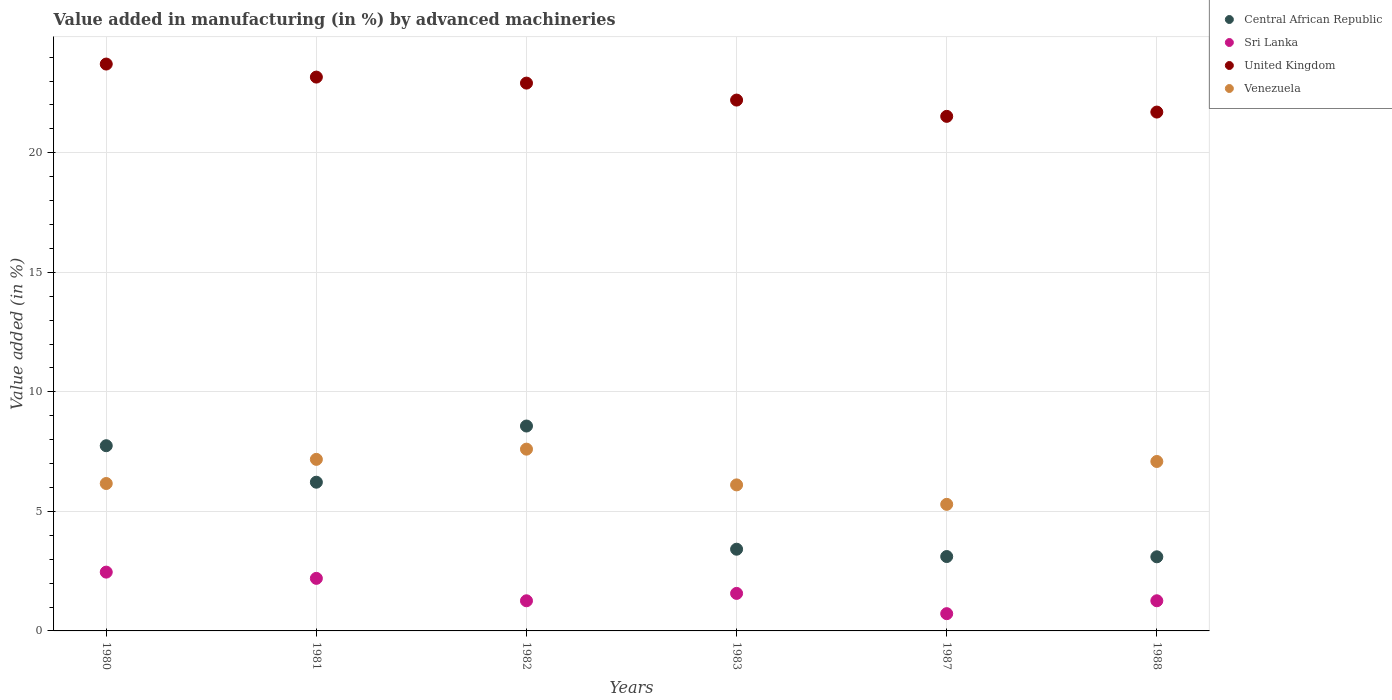How many different coloured dotlines are there?
Give a very brief answer. 4. Is the number of dotlines equal to the number of legend labels?
Your answer should be very brief. Yes. What is the percentage of value added in manufacturing by advanced machineries in Venezuela in 1983?
Your answer should be compact. 6.11. Across all years, what is the maximum percentage of value added in manufacturing by advanced machineries in Central African Republic?
Offer a very short reply. 8.57. Across all years, what is the minimum percentage of value added in manufacturing by advanced machineries in Venezuela?
Give a very brief answer. 5.29. In which year was the percentage of value added in manufacturing by advanced machineries in Central African Republic maximum?
Your response must be concise. 1982. In which year was the percentage of value added in manufacturing by advanced machineries in Central African Republic minimum?
Ensure brevity in your answer.  1988. What is the total percentage of value added in manufacturing by advanced machineries in Sri Lanka in the graph?
Ensure brevity in your answer.  9.47. What is the difference between the percentage of value added in manufacturing by advanced machineries in United Kingdom in 1980 and that in 1987?
Ensure brevity in your answer.  2.19. What is the difference between the percentage of value added in manufacturing by advanced machineries in Sri Lanka in 1981 and the percentage of value added in manufacturing by advanced machineries in Central African Republic in 1982?
Your answer should be compact. -6.37. What is the average percentage of value added in manufacturing by advanced machineries in Sri Lanka per year?
Provide a succinct answer. 1.58. In the year 1981, what is the difference between the percentage of value added in manufacturing by advanced machineries in Central African Republic and percentage of value added in manufacturing by advanced machineries in United Kingdom?
Provide a short and direct response. -16.95. In how many years, is the percentage of value added in manufacturing by advanced machineries in United Kingdom greater than 21 %?
Provide a succinct answer. 6. What is the ratio of the percentage of value added in manufacturing by advanced machineries in Sri Lanka in 1980 to that in 1983?
Your answer should be compact. 1.57. Is the difference between the percentage of value added in manufacturing by advanced machineries in Central African Republic in 1983 and 1988 greater than the difference between the percentage of value added in manufacturing by advanced machineries in United Kingdom in 1983 and 1988?
Your response must be concise. No. What is the difference between the highest and the second highest percentage of value added in manufacturing by advanced machineries in Sri Lanka?
Ensure brevity in your answer.  0.26. What is the difference between the highest and the lowest percentage of value added in manufacturing by advanced machineries in Central African Republic?
Your response must be concise. 5.47. Is the sum of the percentage of value added in manufacturing by advanced machineries in Central African Republic in 1980 and 1983 greater than the maximum percentage of value added in manufacturing by advanced machineries in Venezuela across all years?
Provide a succinct answer. Yes. Is it the case that in every year, the sum of the percentage of value added in manufacturing by advanced machineries in Central African Republic and percentage of value added in manufacturing by advanced machineries in United Kingdom  is greater than the percentage of value added in manufacturing by advanced machineries in Venezuela?
Offer a terse response. Yes. How many dotlines are there?
Keep it short and to the point. 4. How many legend labels are there?
Your answer should be compact. 4. How are the legend labels stacked?
Offer a very short reply. Vertical. What is the title of the graph?
Keep it short and to the point. Value added in manufacturing (in %) by advanced machineries. Does "Vanuatu" appear as one of the legend labels in the graph?
Ensure brevity in your answer.  No. What is the label or title of the X-axis?
Offer a very short reply. Years. What is the label or title of the Y-axis?
Your response must be concise. Value added (in %). What is the Value added (in %) of Central African Republic in 1980?
Make the answer very short. 7.75. What is the Value added (in %) in Sri Lanka in 1980?
Keep it short and to the point. 2.46. What is the Value added (in %) in United Kingdom in 1980?
Offer a terse response. 23.71. What is the Value added (in %) of Venezuela in 1980?
Offer a terse response. 6.17. What is the Value added (in %) in Central African Republic in 1981?
Make the answer very short. 6.22. What is the Value added (in %) in Sri Lanka in 1981?
Provide a succinct answer. 2.2. What is the Value added (in %) of United Kingdom in 1981?
Offer a very short reply. 23.17. What is the Value added (in %) in Venezuela in 1981?
Offer a terse response. 7.18. What is the Value added (in %) in Central African Republic in 1982?
Offer a very short reply. 8.57. What is the Value added (in %) in Sri Lanka in 1982?
Your answer should be compact. 1.26. What is the Value added (in %) of United Kingdom in 1982?
Offer a terse response. 22.91. What is the Value added (in %) in Venezuela in 1982?
Provide a succinct answer. 7.6. What is the Value added (in %) of Central African Republic in 1983?
Your response must be concise. 3.42. What is the Value added (in %) in Sri Lanka in 1983?
Give a very brief answer. 1.57. What is the Value added (in %) of United Kingdom in 1983?
Give a very brief answer. 22.2. What is the Value added (in %) in Venezuela in 1983?
Your answer should be compact. 6.11. What is the Value added (in %) of Central African Republic in 1987?
Provide a short and direct response. 3.11. What is the Value added (in %) of Sri Lanka in 1987?
Make the answer very short. 0.72. What is the Value added (in %) in United Kingdom in 1987?
Your answer should be compact. 21.52. What is the Value added (in %) of Venezuela in 1987?
Give a very brief answer. 5.29. What is the Value added (in %) in Central African Republic in 1988?
Your answer should be very brief. 3.1. What is the Value added (in %) in Sri Lanka in 1988?
Keep it short and to the point. 1.26. What is the Value added (in %) in United Kingdom in 1988?
Keep it short and to the point. 21.7. What is the Value added (in %) in Venezuela in 1988?
Keep it short and to the point. 7.09. Across all years, what is the maximum Value added (in %) in Central African Republic?
Offer a terse response. 8.57. Across all years, what is the maximum Value added (in %) in Sri Lanka?
Your answer should be very brief. 2.46. Across all years, what is the maximum Value added (in %) of United Kingdom?
Make the answer very short. 23.71. Across all years, what is the maximum Value added (in %) in Venezuela?
Your answer should be very brief. 7.6. Across all years, what is the minimum Value added (in %) of Central African Republic?
Your response must be concise. 3.1. Across all years, what is the minimum Value added (in %) in Sri Lanka?
Provide a succinct answer. 0.72. Across all years, what is the minimum Value added (in %) of United Kingdom?
Make the answer very short. 21.52. Across all years, what is the minimum Value added (in %) in Venezuela?
Your response must be concise. 5.29. What is the total Value added (in %) of Central African Republic in the graph?
Your answer should be compact. 32.17. What is the total Value added (in %) of Sri Lanka in the graph?
Offer a very short reply. 9.47. What is the total Value added (in %) of United Kingdom in the graph?
Make the answer very short. 135.22. What is the total Value added (in %) in Venezuela in the graph?
Provide a succinct answer. 39.44. What is the difference between the Value added (in %) of Central African Republic in 1980 and that in 1981?
Provide a succinct answer. 1.53. What is the difference between the Value added (in %) of Sri Lanka in 1980 and that in 1981?
Offer a very short reply. 0.26. What is the difference between the Value added (in %) of United Kingdom in 1980 and that in 1981?
Provide a succinct answer. 0.55. What is the difference between the Value added (in %) of Venezuela in 1980 and that in 1981?
Offer a very short reply. -1.01. What is the difference between the Value added (in %) of Central African Republic in 1980 and that in 1982?
Your response must be concise. -0.82. What is the difference between the Value added (in %) in Sri Lanka in 1980 and that in 1982?
Make the answer very short. 1.2. What is the difference between the Value added (in %) of United Kingdom in 1980 and that in 1982?
Offer a terse response. 0.8. What is the difference between the Value added (in %) of Venezuela in 1980 and that in 1982?
Your response must be concise. -1.44. What is the difference between the Value added (in %) of Central African Republic in 1980 and that in 1983?
Ensure brevity in your answer.  4.33. What is the difference between the Value added (in %) of Sri Lanka in 1980 and that in 1983?
Offer a very short reply. 0.89. What is the difference between the Value added (in %) in United Kingdom in 1980 and that in 1983?
Your answer should be very brief. 1.51. What is the difference between the Value added (in %) in Venezuela in 1980 and that in 1983?
Make the answer very short. 0.06. What is the difference between the Value added (in %) of Central African Republic in 1980 and that in 1987?
Ensure brevity in your answer.  4.64. What is the difference between the Value added (in %) of Sri Lanka in 1980 and that in 1987?
Make the answer very short. 1.74. What is the difference between the Value added (in %) of United Kingdom in 1980 and that in 1987?
Your response must be concise. 2.19. What is the difference between the Value added (in %) in Venezuela in 1980 and that in 1987?
Your answer should be very brief. 0.87. What is the difference between the Value added (in %) in Central African Republic in 1980 and that in 1988?
Ensure brevity in your answer.  4.65. What is the difference between the Value added (in %) of Sri Lanka in 1980 and that in 1988?
Your answer should be very brief. 1.2. What is the difference between the Value added (in %) of United Kingdom in 1980 and that in 1988?
Your answer should be very brief. 2.01. What is the difference between the Value added (in %) in Venezuela in 1980 and that in 1988?
Ensure brevity in your answer.  -0.92. What is the difference between the Value added (in %) of Central African Republic in 1981 and that in 1982?
Your answer should be very brief. -2.35. What is the difference between the Value added (in %) of Sri Lanka in 1981 and that in 1982?
Your response must be concise. 0.94. What is the difference between the Value added (in %) of United Kingdom in 1981 and that in 1982?
Your response must be concise. 0.25. What is the difference between the Value added (in %) in Venezuela in 1981 and that in 1982?
Give a very brief answer. -0.43. What is the difference between the Value added (in %) in Central African Republic in 1981 and that in 1983?
Make the answer very short. 2.8. What is the difference between the Value added (in %) in Sri Lanka in 1981 and that in 1983?
Make the answer very short. 0.63. What is the difference between the Value added (in %) in United Kingdom in 1981 and that in 1983?
Provide a succinct answer. 0.96. What is the difference between the Value added (in %) of Venezuela in 1981 and that in 1983?
Provide a short and direct response. 1.07. What is the difference between the Value added (in %) of Central African Republic in 1981 and that in 1987?
Your response must be concise. 3.11. What is the difference between the Value added (in %) in Sri Lanka in 1981 and that in 1987?
Your response must be concise. 1.48. What is the difference between the Value added (in %) in United Kingdom in 1981 and that in 1987?
Your answer should be very brief. 1.64. What is the difference between the Value added (in %) of Venezuela in 1981 and that in 1987?
Make the answer very short. 1.88. What is the difference between the Value added (in %) of Central African Republic in 1981 and that in 1988?
Keep it short and to the point. 3.12. What is the difference between the Value added (in %) of Sri Lanka in 1981 and that in 1988?
Provide a short and direct response. 0.94. What is the difference between the Value added (in %) of United Kingdom in 1981 and that in 1988?
Offer a very short reply. 1.46. What is the difference between the Value added (in %) in Venezuela in 1981 and that in 1988?
Provide a short and direct response. 0.09. What is the difference between the Value added (in %) in Central African Republic in 1982 and that in 1983?
Keep it short and to the point. 5.15. What is the difference between the Value added (in %) of Sri Lanka in 1982 and that in 1983?
Keep it short and to the point. -0.31. What is the difference between the Value added (in %) of United Kingdom in 1982 and that in 1983?
Ensure brevity in your answer.  0.71. What is the difference between the Value added (in %) in Venezuela in 1982 and that in 1983?
Offer a terse response. 1.5. What is the difference between the Value added (in %) in Central African Republic in 1982 and that in 1987?
Give a very brief answer. 5.46. What is the difference between the Value added (in %) of Sri Lanka in 1982 and that in 1987?
Make the answer very short. 0.54. What is the difference between the Value added (in %) of United Kingdom in 1982 and that in 1987?
Your response must be concise. 1.39. What is the difference between the Value added (in %) of Venezuela in 1982 and that in 1987?
Give a very brief answer. 2.31. What is the difference between the Value added (in %) of Central African Republic in 1982 and that in 1988?
Offer a terse response. 5.47. What is the difference between the Value added (in %) of Sri Lanka in 1982 and that in 1988?
Make the answer very short. -0. What is the difference between the Value added (in %) in United Kingdom in 1982 and that in 1988?
Provide a short and direct response. 1.21. What is the difference between the Value added (in %) in Venezuela in 1982 and that in 1988?
Offer a very short reply. 0.52. What is the difference between the Value added (in %) of Central African Republic in 1983 and that in 1987?
Ensure brevity in your answer.  0.31. What is the difference between the Value added (in %) of Sri Lanka in 1983 and that in 1987?
Make the answer very short. 0.85. What is the difference between the Value added (in %) of United Kingdom in 1983 and that in 1987?
Offer a terse response. 0.68. What is the difference between the Value added (in %) of Venezuela in 1983 and that in 1987?
Your response must be concise. 0.81. What is the difference between the Value added (in %) of Central African Republic in 1983 and that in 1988?
Your response must be concise. 0.32. What is the difference between the Value added (in %) of Sri Lanka in 1983 and that in 1988?
Your response must be concise. 0.31. What is the difference between the Value added (in %) of United Kingdom in 1983 and that in 1988?
Provide a short and direct response. 0.5. What is the difference between the Value added (in %) of Venezuela in 1983 and that in 1988?
Offer a very short reply. -0.98. What is the difference between the Value added (in %) of Central African Republic in 1987 and that in 1988?
Ensure brevity in your answer.  0.01. What is the difference between the Value added (in %) in Sri Lanka in 1987 and that in 1988?
Ensure brevity in your answer.  -0.54. What is the difference between the Value added (in %) of United Kingdom in 1987 and that in 1988?
Ensure brevity in your answer.  -0.18. What is the difference between the Value added (in %) in Venezuela in 1987 and that in 1988?
Provide a succinct answer. -1.79. What is the difference between the Value added (in %) of Central African Republic in 1980 and the Value added (in %) of Sri Lanka in 1981?
Give a very brief answer. 5.55. What is the difference between the Value added (in %) in Central African Republic in 1980 and the Value added (in %) in United Kingdom in 1981?
Ensure brevity in your answer.  -15.42. What is the difference between the Value added (in %) in Central African Republic in 1980 and the Value added (in %) in Venezuela in 1981?
Give a very brief answer. 0.57. What is the difference between the Value added (in %) of Sri Lanka in 1980 and the Value added (in %) of United Kingdom in 1981?
Offer a very short reply. -20.71. What is the difference between the Value added (in %) in Sri Lanka in 1980 and the Value added (in %) in Venezuela in 1981?
Keep it short and to the point. -4.72. What is the difference between the Value added (in %) in United Kingdom in 1980 and the Value added (in %) in Venezuela in 1981?
Your answer should be compact. 16.54. What is the difference between the Value added (in %) in Central African Republic in 1980 and the Value added (in %) in Sri Lanka in 1982?
Your response must be concise. 6.49. What is the difference between the Value added (in %) of Central African Republic in 1980 and the Value added (in %) of United Kingdom in 1982?
Your answer should be compact. -15.17. What is the difference between the Value added (in %) of Central African Republic in 1980 and the Value added (in %) of Venezuela in 1982?
Your response must be concise. 0.14. What is the difference between the Value added (in %) of Sri Lanka in 1980 and the Value added (in %) of United Kingdom in 1982?
Give a very brief answer. -20.45. What is the difference between the Value added (in %) of Sri Lanka in 1980 and the Value added (in %) of Venezuela in 1982?
Provide a succinct answer. -5.14. What is the difference between the Value added (in %) of United Kingdom in 1980 and the Value added (in %) of Venezuela in 1982?
Give a very brief answer. 16.11. What is the difference between the Value added (in %) in Central African Republic in 1980 and the Value added (in %) in Sri Lanka in 1983?
Your answer should be compact. 6.18. What is the difference between the Value added (in %) in Central African Republic in 1980 and the Value added (in %) in United Kingdom in 1983?
Your answer should be compact. -14.46. What is the difference between the Value added (in %) of Central African Republic in 1980 and the Value added (in %) of Venezuela in 1983?
Your response must be concise. 1.64. What is the difference between the Value added (in %) in Sri Lanka in 1980 and the Value added (in %) in United Kingdom in 1983?
Your response must be concise. -19.75. What is the difference between the Value added (in %) in Sri Lanka in 1980 and the Value added (in %) in Venezuela in 1983?
Your answer should be very brief. -3.65. What is the difference between the Value added (in %) in United Kingdom in 1980 and the Value added (in %) in Venezuela in 1983?
Offer a very short reply. 17.6. What is the difference between the Value added (in %) in Central African Republic in 1980 and the Value added (in %) in Sri Lanka in 1987?
Offer a very short reply. 7.02. What is the difference between the Value added (in %) in Central African Republic in 1980 and the Value added (in %) in United Kingdom in 1987?
Give a very brief answer. -13.78. What is the difference between the Value added (in %) in Central African Republic in 1980 and the Value added (in %) in Venezuela in 1987?
Your answer should be compact. 2.45. What is the difference between the Value added (in %) of Sri Lanka in 1980 and the Value added (in %) of United Kingdom in 1987?
Offer a very short reply. -19.06. What is the difference between the Value added (in %) of Sri Lanka in 1980 and the Value added (in %) of Venezuela in 1987?
Provide a short and direct response. -2.83. What is the difference between the Value added (in %) in United Kingdom in 1980 and the Value added (in %) in Venezuela in 1987?
Your answer should be very brief. 18.42. What is the difference between the Value added (in %) in Central African Republic in 1980 and the Value added (in %) in Sri Lanka in 1988?
Your answer should be very brief. 6.49. What is the difference between the Value added (in %) in Central African Republic in 1980 and the Value added (in %) in United Kingdom in 1988?
Keep it short and to the point. -13.96. What is the difference between the Value added (in %) of Central African Republic in 1980 and the Value added (in %) of Venezuela in 1988?
Keep it short and to the point. 0.66. What is the difference between the Value added (in %) of Sri Lanka in 1980 and the Value added (in %) of United Kingdom in 1988?
Offer a very short reply. -19.24. What is the difference between the Value added (in %) of Sri Lanka in 1980 and the Value added (in %) of Venezuela in 1988?
Your answer should be compact. -4.63. What is the difference between the Value added (in %) in United Kingdom in 1980 and the Value added (in %) in Venezuela in 1988?
Your response must be concise. 16.62. What is the difference between the Value added (in %) of Central African Republic in 1981 and the Value added (in %) of Sri Lanka in 1982?
Provide a short and direct response. 4.96. What is the difference between the Value added (in %) of Central African Republic in 1981 and the Value added (in %) of United Kingdom in 1982?
Provide a succinct answer. -16.69. What is the difference between the Value added (in %) of Central African Republic in 1981 and the Value added (in %) of Venezuela in 1982?
Provide a short and direct response. -1.38. What is the difference between the Value added (in %) in Sri Lanka in 1981 and the Value added (in %) in United Kingdom in 1982?
Give a very brief answer. -20.72. What is the difference between the Value added (in %) of Sri Lanka in 1981 and the Value added (in %) of Venezuela in 1982?
Your answer should be very brief. -5.4. What is the difference between the Value added (in %) in United Kingdom in 1981 and the Value added (in %) in Venezuela in 1982?
Give a very brief answer. 15.56. What is the difference between the Value added (in %) in Central African Republic in 1981 and the Value added (in %) in Sri Lanka in 1983?
Your response must be concise. 4.65. What is the difference between the Value added (in %) in Central African Republic in 1981 and the Value added (in %) in United Kingdom in 1983?
Make the answer very short. -15.98. What is the difference between the Value added (in %) in Central African Republic in 1981 and the Value added (in %) in Venezuela in 1983?
Provide a short and direct response. 0.11. What is the difference between the Value added (in %) of Sri Lanka in 1981 and the Value added (in %) of United Kingdom in 1983?
Offer a very short reply. -20.01. What is the difference between the Value added (in %) in Sri Lanka in 1981 and the Value added (in %) in Venezuela in 1983?
Keep it short and to the point. -3.91. What is the difference between the Value added (in %) of United Kingdom in 1981 and the Value added (in %) of Venezuela in 1983?
Offer a terse response. 17.06. What is the difference between the Value added (in %) of Central African Republic in 1981 and the Value added (in %) of Sri Lanka in 1987?
Provide a succinct answer. 5.5. What is the difference between the Value added (in %) in Central African Republic in 1981 and the Value added (in %) in United Kingdom in 1987?
Keep it short and to the point. -15.3. What is the difference between the Value added (in %) in Central African Republic in 1981 and the Value added (in %) in Venezuela in 1987?
Your answer should be compact. 0.93. What is the difference between the Value added (in %) in Sri Lanka in 1981 and the Value added (in %) in United Kingdom in 1987?
Make the answer very short. -19.33. What is the difference between the Value added (in %) of Sri Lanka in 1981 and the Value added (in %) of Venezuela in 1987?
Provide a succinct answer. -3.1. What is the difference between the Value added (in %) in United Kingdom in 1981 and the Value added (in %) in Venezuela in 1987?
Ensure brevity in your answer.  17.87. What is the difference between the Value added (in %) of Central African Republic in 1981 and the Value added (in %) of Sri Lanka in 1988?
Ensure brevity in your answer.  4.96. What is the difference between the Value added (in %) in Central African Republic in 1981 and the Value added (in %) in United Kingdom in 1988?
Offer a very short reply. -15.48. What is the difference between the Value added (in %) of Central African Republic in 1981 and the Value added (in %) of Venezuela in 1988?
Offer a very short reply. -0.87. What is the difference between the Value added (in %) in Sri Lanka in 1981 and the Value added (in %) in United Kingdom in 1988?
Offer a very short reply. -19.5. What is the difference between the Value added (in %) of Sri Lanka in 1981 and the Value added (in %) of Venezuela in 1988?
Ensure brevity in your answer.  -4.89. What is the difference between the Value added (in %) of United Kingdom in 1981 and the Value added (in %) of Venezuela in 1988?
Ensure brevity in your answer.  16.08. What is the difference between the Value added (in %) in Central African Republic in 1982 and the Value added (in %) in Sri Lanka in 1983?
Offer a very short reply. 7. What is the difference between the Value added (in %) in Central African Republic in 1982 and the Value added (in %) in United Kingdom in 1983?
Make the answer very short. -13.63. What is the difference between the Value added (in %) of Central African Republic in 1982 and the Value added (in %) of Venezuela in 1983?
Give a very brief answer. 2.46. What is the difference between the Value added (in %) of Sri Lanka in 1982 and the Value added (in %) of United Kingdom in 1983?
Offer a very short reply. -20.94. What is the difference between the Value added (in %) in Sri Lanka in 1982 and the Value added (in %) in Venezuela in 1983?
Keep it short and to the point. -4.85. What is the difference between the Value added (in %) of United Kingdom in 1982 and the Value added (in %) of Venezuela in 1983?
Offer a very short reply. 16.81. What is the difference between the Value added (in %) in Central African Republic in 1982 and the Value added (in %) in Sri Lanka in 1987?
Make the answer very short. 7.85. What is the difference between the Value added (in %) of Central African Republic in 1982 and the Value added (in %) of United Kingdom in 1987?
Make the answer very short. -12.95. What is the difference between the Value added (in %) in Central African Republic in 1982 and the Value added (in %) in Venezuela in 1987?
Offer a very short reply. 3.28. What is the difference between the Value added (in %) of Sri Lanka in 1982 and the Value added (in %) of United Kingdom in 1987?
Your answer should be compact. -20.26. What is the difference between the Value added (in %) in Sri Lanka in 1982 and the Value added (in %) in Venezuela in 1987?
Keep it short and to the point. -4.03. What is the difference between the Value added (in %) of United Kingdom in 1982 and the Value added (in %) of Venezuela in 1987?
Make the answer very short. 17.62. What is the difference between the Value added (in %) of Central African Republic in 1982 and the Value added (in %) of Sri Lanka in 1988?
Give a very brief answer. 7.31. What is the difference between the Value added (in %) in Central African Republic in 1982 and the Value added (in %) in United Kingdom in 1988?
Provide a succinct answer. -13.13. What is the difference between the Value added (in %) in Central African Republic in 1982 and the Value added (in %) in Venezuela in 1988?
Provide a short and direct response. 1.48. What is the difference between the Value added (in %) in Sri Lanka in 1982 and the Value added (in %) in United Kingdom in 1988?
Your response must be concise. -20.44. What is the difference between the Value added (in %) of Sri Lanka in 1982 and the Value added (in %) of Venezuela in 1988?
Ensure brevity in your answer.  -5.83. What is the difference between the Value added (in %) of United Kingdom in 1982 and the Value added (in %) of Venezuela in 1988?
Ensure brevity in your answer.  15.83. What is the difference between the Value added (in %) in Central African Republic in 1983 and the Value added (in %) in Sri Lanka in 1987?
Keep it short and to the point. 2.7. What is the difference between the Value added (in %) of Central African Republic in 1983 and the Value added (in %) of United Kingdom in 1987?
Your answer should be compact. -18.11. What is the difference between the Value added (in %) in Central African Republic in 1983 and the Value added (in %) in Venezuela in 1987?
Your answer should be compact. -1.88. What is the difference between the Value added (in %) in Sri Lanka in 1983 and the Value added (in %) in United Kingdom in 1987?
Make the answer very short. -19.95. What is the difference between the Value added (in %) of Sri Lanka in 1983 and the Value added (in %) of Venezuela in 1987?
Ensure brevity in your answer.  -3.73. What is the difference between the Value added (in %) in United Kingdom in 1983 and the Value added (in %) in Venezuela in 1987?
Keep it short and to the point. 16.91. What is the difference between the Value added (in %) of Central African Republic in 1983 and the Value added (in %) of Sri Lanka in 1988?
Offer a very short reply. 2.16. What is the difference between the Value added (in %) of Central African Republic in 1983 and the Value added (in %) of United Kingdom in 1988?
Your response must be concise. -18.29. What is the difference between the Value added (in %) of Central African Republic in 1983 and the Value added (in %) of Venezuela in 1988?
Your response must be concise. -3.67. What is the difference between the Value added (in %) in Sri Lanka in 1983 and the Value added (in %) in United Kingdom in 1988?
Keep it short and to the point. -20.13. What is the difference between the Value added (in %) in Sri Lanka in 1983 and the Value added (in %) in Venezuela in 1988?
Give a very brief answer. -5.52. What is the difference between the Value added (in %) in United Kingdom in 1983 and the Value added (in %) in Venezuela in 1988?
Your answer should be very brief. 15.12. What is the difference between the Value added (in %) in Central African Republic in 1987 and the Value added (in %) in Sri Lanka in 1988?
Give a very brief answer. 1.85. What is the difference between the Value added (in %) in Central African Republic in 1987 and the Value added (in %) in United Kingdom in 1988?
Ensure brevity in your answer.  -18.59. What is the difference between the Value added (in %) of Central African Republic in 1987 and the Value added (in %) of Venezuela in 1988?
Offer a terse response. -3.98. What is the difference between the Value added (in %) in Sri Lanka in 1987 and the Value added (in %) in United Kingdom in 1988?
Make the answer very short. -20.98. What is the difference between the Value added (in %) in Sri Lanka in 1987 and the Value added (in %) in Venezuela in 1988?
Provide a short and direct response. -6.37. What is the difference between the Value added (in %) of United Kingdom in 1987 and the Value added (in %) of Venezuela in 1988?
Give a very brief answer. 14.44. What is the average Value added (in %) in Central African Republic per year?
Keep it short and to the point. 5.36. What is the average Value added (in %) of Sri Lanka per year?
Offer a terse response. 1.58. What is the average Value added (in %) of United Kingdom per year?
Keep it short and to the point. 22.54. What is the average Value added (in %) in Venezuela per year?
Your answer should be compact. 6.57. In the year 1980, what is the difference between the Value added (in %) of Central African Republic and Value added (in %) of Sri Lanka?
Ensure brevity in your answer.  5.29. In the year 1980, what is the difference between the Value added (in %) in Central African Republic and Value added (in %) in United Kingdom?
Make the answer very short. -15.96. In the year 1980, what is the difference between the Value added (in %) of Central African Republic and Value added (in %) of Venezuela?
Make the answer very short. 1.58. In the year 1980, what is the difference between the Value added (in %) in Sri Lanka and Value added (in %) in United Kingdom?
Offer a terse response. -21.25. In the year 1980, what is the difference between the Value added (in %) of Sri Lanka and Value added (in %) of Venezuela?
Provide a short and direct response. -3.71. In the year 1980, what is the difference between the Value added (in %) of United Kingdom and Value added (in %) of Venezuela?
Your response must be concise. 17.55. In the year 1981, what is the difference between the Value added (in %) in Central African Republic and Value added (in %) in Sri Lanka?
Your answer should be very brief. 4.02. In the year 1981, what is the difference between the Value added (in %) in Central African Republic and Value added (in %) in United Kingdom?
Give a very brief answer. -16.95. In the year 1981, what is the difference between the Value added (in %) of Central African Republic and Value added (in %) of Venezuela?
Provide a succinct answer. -0.96. In the year 1981, what is the difference between the Value added (in %) of Sri Lanka and Value added (in %) of United Kingdom?
Make the answer very short. -20.97. In the year 1981, what is the difference between the Value added (in %) in Sri Lanka and Value added (in %) in Venezuela?
Your answer should be compact. -4.98. In the year 1981, what is the difference between the Value added (in %) in United Kingdom and Value added (in %) in Venezuela?
Your answer should be compact. 15.99. In the year 1982, what is the difference between the Value added (in %) of Central African Republic and Value added (in %) of Sri Lanka?
Keep it short and to the point. 7.31. In the year 1982, what is the difference between the Value added (in %) in Central African Republic and Value added (in %) in United Kingdom?
Give a very brief answer. -14.34. In the year 1982, what is the difference between the Value added (in %) of Central African Republic and Value added (in %) of Venezuela?
Keep it short and to the point. 0.97. In the year 1982, what is the difference between the Value added (in %) of Sri Lanka and Value added (in %) of United Kingdom?
Your answer should be compact. -21.65. In the year 1982, what is the difference between the Value added (in %) of Sri Lanka and Value added (in %) of Venezuela?
Make the answer very short. -6.34. In the year 1982, what is the difference between the Value added (in %) in United Kingdom and Value added (in %) in Venezuela?
Offer a terse response. 15.31. In the year 1983, what is the difference between the Value added (in %) of Central African Republic and Value added (in %) of Sri Lanka?
Offer a terse response. 1.85. In the year 1983, what is the difference between the Value added (in %) of Central African Republic and Value added (in %) of United Kingdom?
Offer a terse response. -18.79. In the year 1983, what is the difference between the Value added (in %) of Central African Republic and Value added (in %) of Venezuela?
Provide a short and direct response. -2.69. In the year 1983, what is the difference between the Value added (in %) in Sri Lanka and Value added (in %) in United Kingdom?
Your answer should be very brief. -20.64. In the year 1983, what is the difference between the Value added (in %) in Sri Lanka and Value added (in %) in Venezuela?
Ensure brevity in your answer.  -4.54. In the year 1983, what is the difference between the Value added (in %) in United Kingdom and Value added (in %) in Venezuela?
Provide a succinct answer. 16.1. In the year 1987, what is the difference between the Value added (in %) of Central African Republic and Value added (in %) of Sri Lanka?
Keep it short and to the point. 2.39. In the year 1987, what is the difference between the Value added (in %) in Central African Republic and Value added (in %) in United Kingdom?
Provide a short and direct response. -18.41. In the year 1987, what is the difference between the Value added (in %) in Central African Republic and Value added (in %) in Venezuela?
Offer a terse response. -2.18. In the year 1987, what is the difference between the Value added (in %) of Sri Lanka and Value added (in %) of United Kingdom?
Provide a short and direct response. -20.8. In the year 1987, what is the difference between the Value added (in %) of Sri Lanka and Value added (in %) of Venezuela?
Make the answer very short. -4.57. In the year 1987, what is the difference between the Value added (in %) of United Kingdom and Value added (in %) of Venezuela?
Keep it short and to the point. 16.23. In the year 1988, what is the difference between the Value added (in %) in Central African Republic and Value added (in %) in Sri Lanka?
Offer a very short reply. 1.84. In the year 1988, what is the difference between the Value added (in %) in Central African Republic and Value added (in %) in United Kingdom?
Ensure brevity in your answer.  -18.6. In the year 1988, what is the difference between the Value added (in %) of Central African Republic and Value added (in %) of Venezuela?
Provide a succinct answer. -3.99. In the year 1988, what is the difference between the Value added (in %) of Sri Lanka and Value added (in %) of United Kingdom?
Keep it short and to the point. -20.44. In the year 1988, what is the difference between the Value added (in %) of Sri Lanka and Value added (in %) of Venezuela?
Keep it short and to the point. -5.83. In the year 1988, what is the difference between the Value added (in %) of United Kingdom and Value added (in %) of Venezuela?
Your answer should be very brief. 14.62. What is the ratio of the Value added (in %) of Central African Republic in 1980 to that in 1981?
Your response must be concise. 1.25. What is the ratio of the Value added (in %) of Sri Lanka in 1980 to that in 1981?
Make the answer very short. 1.12. What is the ratio of the Value added (in %) of United Kingdom in 1980 to that in 1981?
Provide a short and direct response. 1.02. What is the ratio of the Value added (in %) in Venezuela in 1980 to that in 1981?
Your answer should be compact. 0.86. What is the ratio of the Value added (in %) of Central African Republic in 1980 to that in 1982?
Offer a terse response. 0.9. What is the ratio of the Value added (in %) in Sri Lanka in 1980 to that in 1982?
Give a very brief answer. 1.95. What is the ratio of the Value added (in %) of United Kingdom in 1980 to that in 1982?
Provide a short and direct response. 1.03. What is the ratio of the Value added (in %) in Venezuela in 1980 to that in 1982?
Your response must be concise. 0.81. What is the ratio of the Value added (in %) of Central African Republic in 1980 to that in 1983?
Your answer should be compact. 2.27. What is the ratio of the Value added (in %) in Sri Lanka in 1980 to that in 1983?
Your answer should be compact. 1.57. What is the ratio of the Value added (in %) of United Kingdom in 1980 to that in 1983?
Keep it short and to the point. 1.07. What is the ratio of the Value added (in %) of Venezuela in 1980 to that in 1983?
Your answer should be compact. 1.01. What is the ratio of the Value added (in %) of Central African Republic in 1980 to that in 1987?
Provide a succinct answer. 2.49. What is the ratio of the Value added (in %) of Sri Lanka in 1980 to that in 1987?
Offer a terse response. 3.41. What is the ratio of the Value added (in %) in United Kingdom in 1980 to that in 1987?
Your answer should be compact. 1.1. What is the ratio of the Value added (in %) in Venezuela in 1980 to that in 1987?
Offer a very short reply. 1.16. What is the ratio of the Value added (in %) in Central African Republic in 1980 to that in 1988?
Provide a short and direct response. 2.5. What is the ratio of the Value added (in %) of Sri Lanka in 1980 to that in 1988?
Provide a short and direct response. 1.95. What is the ratio of the Value added (in %) in United Kingdom in 1980 to that in 1988?
Your answer should be compact. 1.09. What is the ratio of the Value added (in %) of Venezuela in 1980 to that in 1988?
Provide a short and direct response. 0.87. What is the ratio of the Value added (in %) of Central African Republic in 1981 to that in 1982?
Give a very brief answer. 0.73. What is the ratio of the Value added (in %) of Sri Lanka in 1981 to that in 1982?
Keep it short and to the point. 1.74. What is the ratio of the Value added (in %) of United Kingdom in 1981 to that in 1982?
Ensure brevity in your answer.  1.01. What is the ratio of the Value added (in %) of Venezuela in 1981 to that in 1982?
Keep it short and to the point. 0.94. What is the ratio of the Value added (in %) of Central African Republic in 1981 to that in 1983?
Ensure brevity in your answer.  1.82. What is the ratio of the Value added (in %) in Sri Lanka in 1981 to that in 1983?
Your answer should be very brief. 1.4. What is the ratio of the Value added (in %) in United Kingdom in 1981 to that in 1983?
Provide a succinct answer. 1.04. What is the ratio of the Value added (in %) in Venezuela in 1981 to that in 1983?
Provide a short and direct response. 1.17. What is the ratio of the Value added (in %) in Central African Republic in 1981 to that in 1987?
Offer a very short reply. 2. What is the ratio of the Value added (in %) in Sri Lanka in 1981 to that in 1987?
Provide a succinct answer. 3.04. What is the ratio of the Value added (in %) of United Kingdom in 1981 to that in 1987?
Provide a succinct answer. 1.08. What is the ratio of the Value added (in %) in Venezuela in 1981 to that in 1987?
Offer a very short reply. 1.36. What is the ratio of the Value added (in %) in Central African Republic in 1981 to that in 1988?
Your answer should be compact. 2.01. What is the ratio of the Value added (in %) in Sri Lanka in 1981 to that in 1988?
Keep it short and to the point. 1.74. What is the ratio of the Value added (in %) of United Kingdom in 1981 to that in 1988?
Offer a very short reply. 1.07. What is the ratio of the Value added (in %) in Venezuela in 1981 to that in 1988?
Make the answer very short. 1.01. What is the ratio of the Value added (in %) in Central African Republic in 1982 to that in 1983?
Your response must be concise. 2.51. What is the ratio of the Value added (in %) of Sri Lanka in 1982 to that in 1983?
Provide a short and direct response. 0.8. What is the ratio of the Value added (in %) of United Kingdom in 1982 to that in 1983?
Ensure brevity in your answer.  1.03. What is the ratio of the Value added (in %) of Venezuela in 1982 to that in 1983?
Make the answer very short. 1.24. What is the ratio of the Value added (in %) in Central African Republic in 1982 to that in 1987?
Ensure brevity in your answer.  2.75. What is the ratio of the Value added (in %) in Sri Lanka in 1982 to that in 1987?
Provide a succinct answer. 1.75. What is the ratio of the Value added (in %) in United Kingdom in 1982 to that in 1987?
Give a very brief answer. 1.06. What is the ratio of the Value added (in %) in Venezuela in 1982 to that in 1987?
Your response must be concise. 1.44. What is the ratio of the Value added (in %) of Central African Republic in 1982 to that in 1988?
Offer a very short reply. 2.76. What is the ratio of the Value added (in %) of Sri Lanka in 1982 to that in 1988?
Make the answer very short. 1. What is the ratio of the Value added (in %) in United Kingdom in 1982 to that in 1988?
Keep it short and to the point. 1.06. What is the ratio of the Value added (in %) of Venezuela in 1982 to that in 1988?
Provide a succinct answer. 1.07. What is the ratio of the Value added (in %) of Central African Republic in 1983 to that in 1987?
Ensure brevity in your answer.  1.1. What is the ratio of the Value added (in %) of Sri Lanka in 1983 to that in 1987?
Your response must be concise. 2.17. What is the ratio of the Value added (in %) of United Kingdom in 1983 to that in 1987?
Keep it short and to the point. 1.03. What is the ratio of the Value added (in %) of Venezuela in 1983 to that in 1987?
Provide a succinct answer. 1.15. What is the ratio of the Value added (in %) in Central African Republic in 1983 to that in 1988?
Ensure brevity in your answer.  1.1. What is the ratio of the Value added (in %) of Sri Lanka in 1983 to that in 1988?
Keep it short and to the point. 1.24. What is the ratio of the Value added (in %) in United Kingdom in 1983 to that in 1988?
Provide a succinct answer. 1.02. What is the ratio of the Value added (in %) of Venezuela in 1983 to that in 1988?
Your answer should be very brief. 0.86. What is the ratio of the Value added (in %) in Sri Lanka in 1987 to that in 1988?
Provide a short and direct response. 0.57. What is the ratio of the Value added (in %) in United Kingdom in 1987 to that in 1988?
Provide a short and direct response. 0.99. What is the ratio of the Value added (in %) of Venezuela in 1987 to that in 1988?
Provide a succinct answer. 0.75. What is the difference between the highest and the second highest Value added (in %) in Central African Republic?
Provide a succinct answer. 0.82. What is the difference between the highest and the second highest Value added (in %) of Sri Lanka?
Offer a terse response. 0.26. What is the difference between the highest and the second highest Value added (in %) in United Kingdom?
Make the answer very short. 0.55. What is the difference between the highest and the second highest Value added (in %) in Venezuela?
Your answer should be compact. 0.43. What is the difference between the highest and the lowest Value added (in %) of Central African Republic?
Offer a very short reply. 5.47. What is the difference between the highest and the lowest Value added (in %) in Sri Lanka?
Provide a succinct answer. 1.74. What is the difference between the highest and the lowest Value added (in %) in United Kingdom?
Your answer should be compact. 2.19. What is the difference between the highest and the lowest Value added (in %) in Venezuela?
Provide a short and direct response. 2.31. 